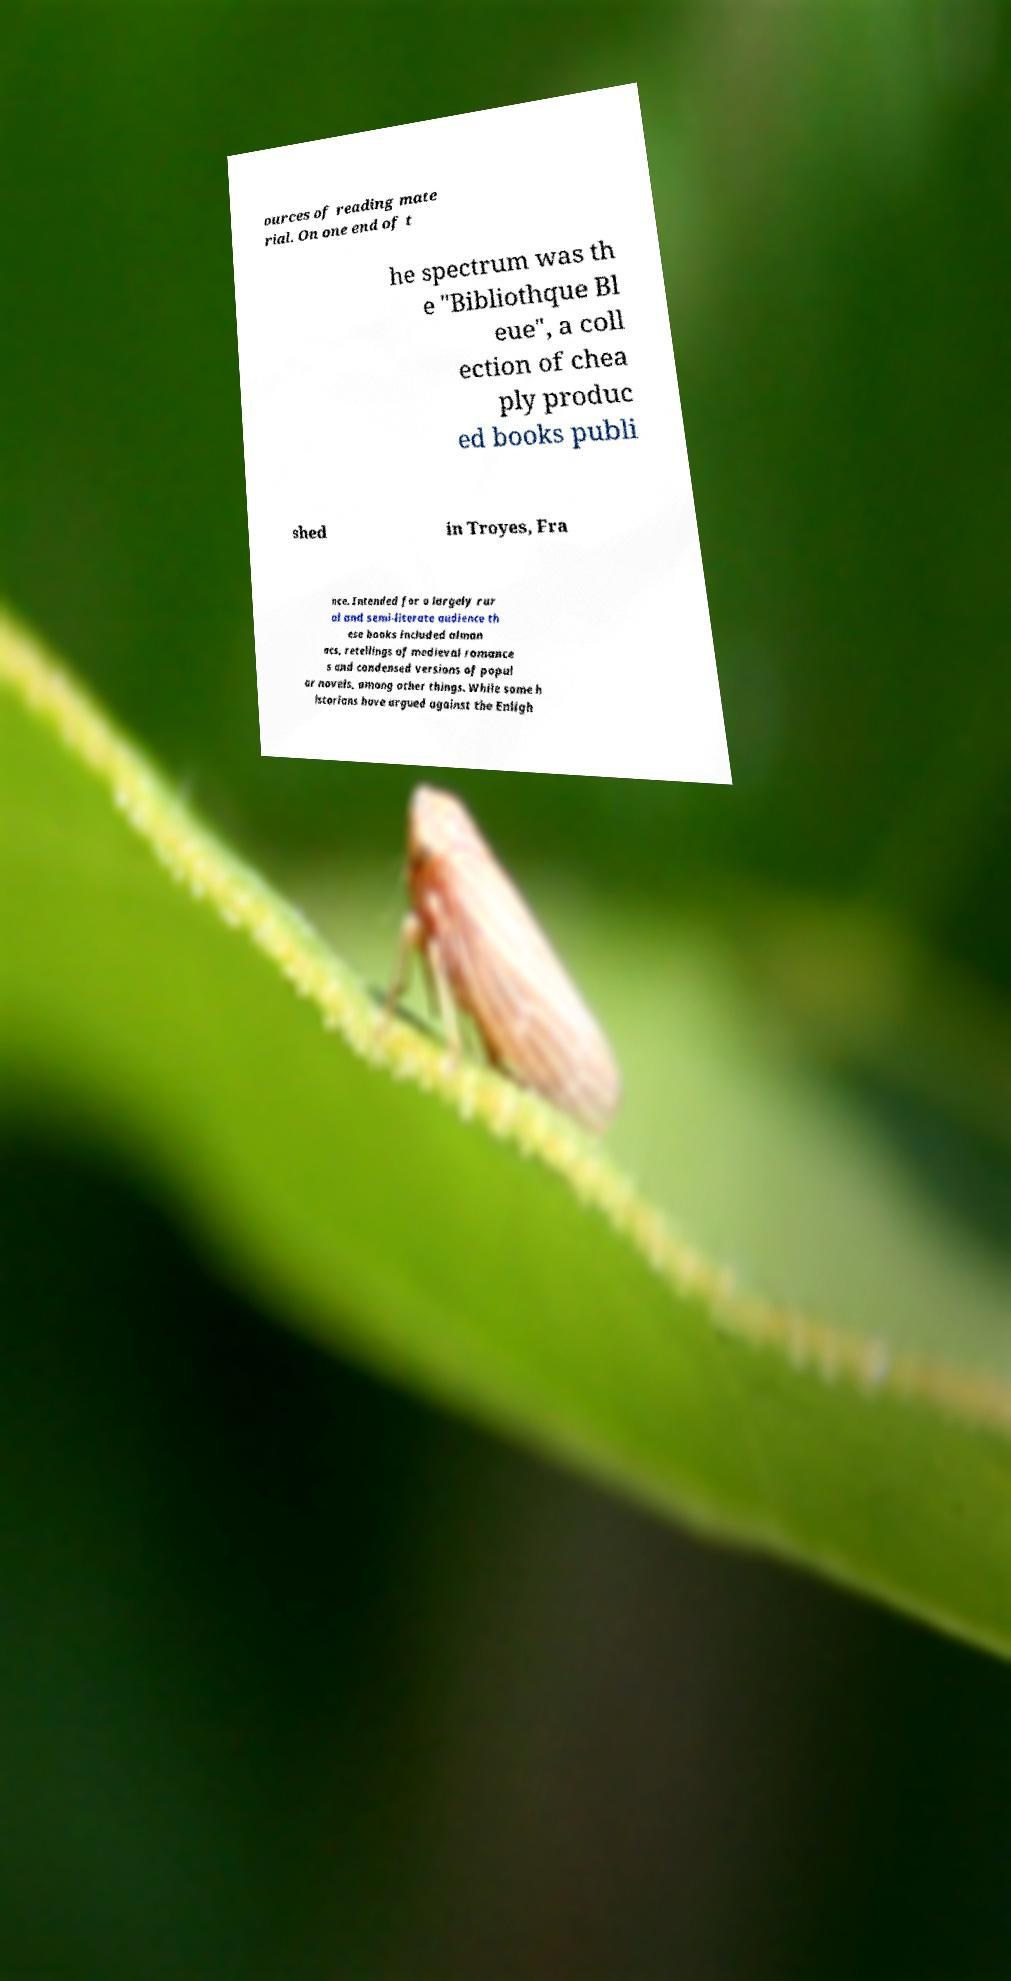Can you accurately transcribe the text from the provided image for me? ources of reading mate rial. On one end of t he spectrum was th e "Bibliothque Bl eue", a coll ection of chea ply produc ed books publi shed in Troyes, Fra nce. Intended for a largely rur al and semi-literate audience th ese books included alman acs, retellings of medieval romance s and condensed versions of popul ar novels, among other things. While some h istorians have argued against the Enligh 